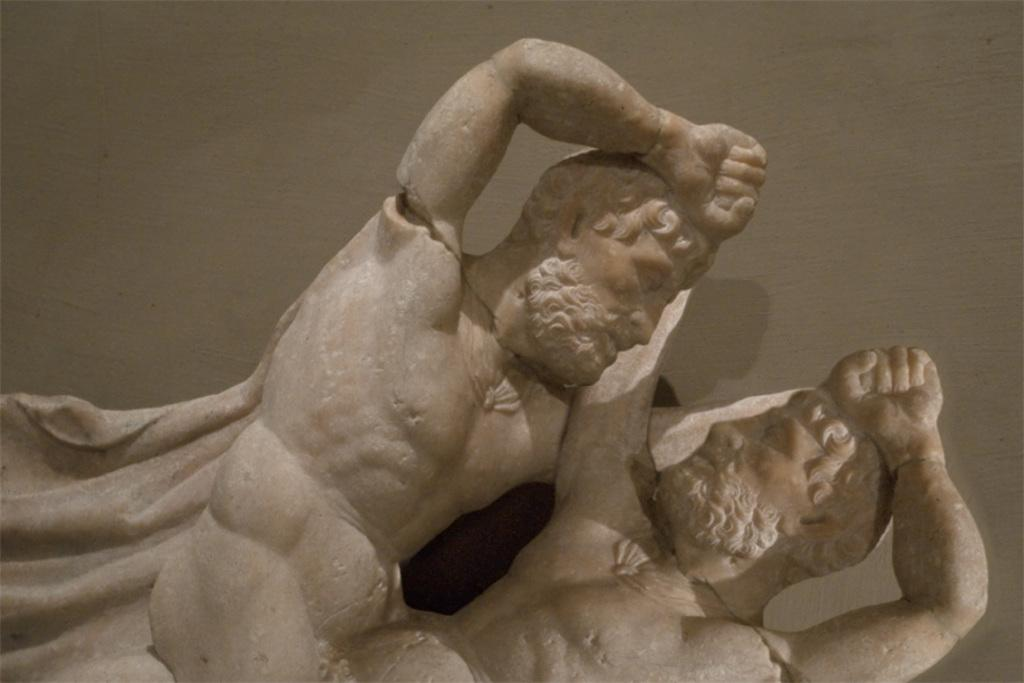What is depicted in the image? There are statues of two people in the image. What can be observed about the background of the image? The background of the image is cream-colored. What type of power source is required for the statues to function in the image? There is no indication in the image that the statues are functional or require a power source. 